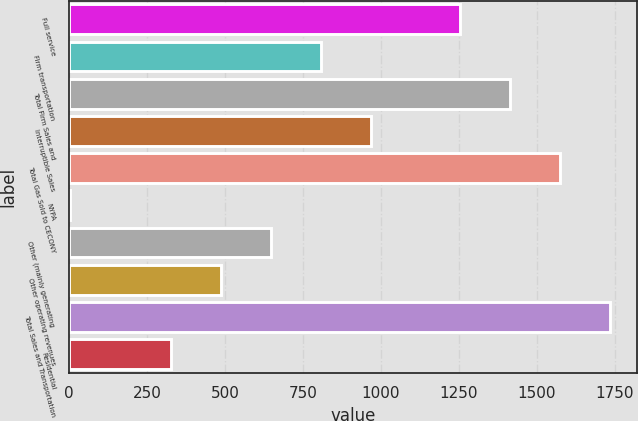Convert chart. <chart><loc_0><loc_0><loc_500><loc_500><bar_chart><fcel>Full service<fcel>Firm transportation<fcel>Total Firm Sales and<fcel>Interruptible Sales<fcel>Total Gas Sold to CECONY<fcel>NYPA<fcel>Other (mainly generating<fcel>Other operating revenues<fcel>Total Sales and Transportation<fcel>Residential<nl><fcel>1252<fcel>808.5<fcel>1412.9<fcel>969.4<fcel>1573.8<fcel>4<fcel>647.6<fcel>486.7<fcel>1734.7<fcel>325.8<nl></chart> 